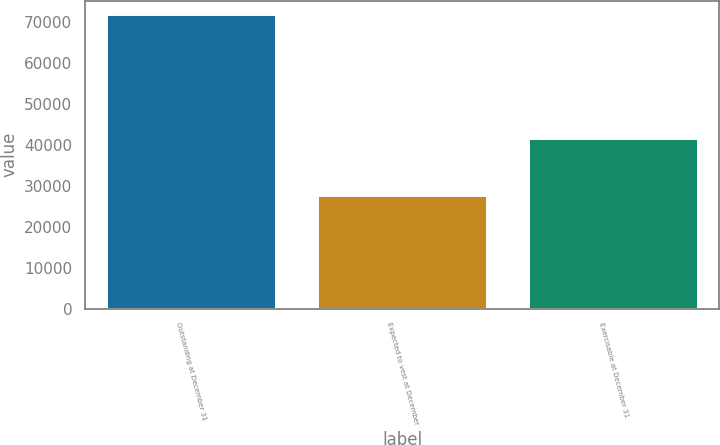Convert chart to OTSL. <chart><loc_0><loc_0><loc_500><loc_500><bar_chart><fcel>Outstanding at December 31<fcel>Expected to vest at December<fcel>Exercisable at December 31<nl><fcel>71702<fcel>27606<fcel>41570<nl></chart> 